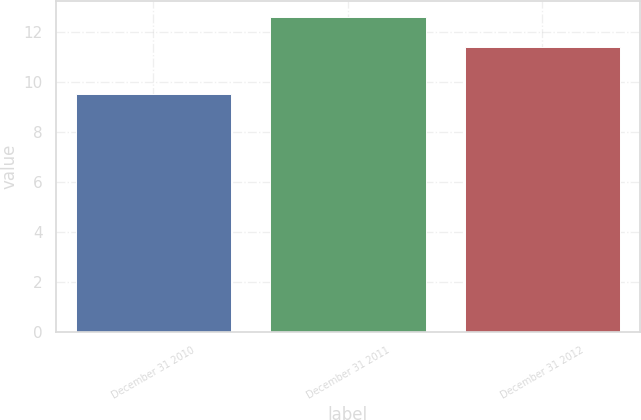Convert chart to OTSL. <chart><loc_0><loc_0><loc_500><loc_500><bar_chart><fcel>December 31 2010<fcel>December 31 2011<fcel>December 31 2012<nl><fcel>9.5<fcel>12.6<fcel>11.4<nl></chart> 